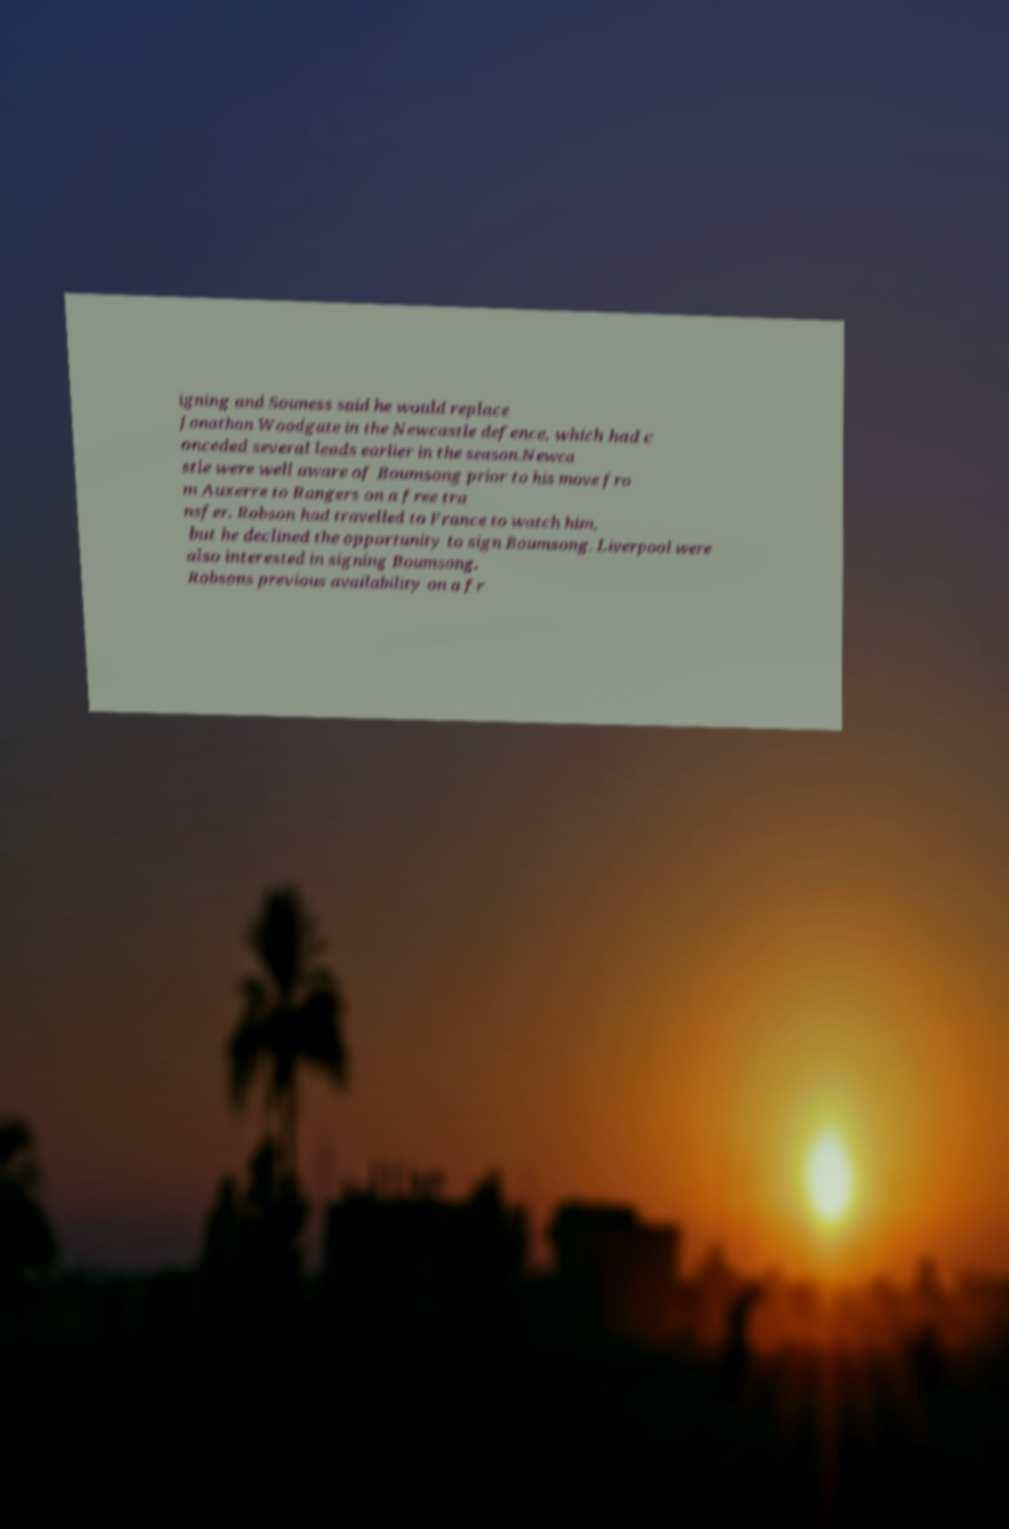There's text embedded in this image that I need extracted. Can you transcribe it verbatim? igning and Souness said he would replace Jonathan Woodgate in the Newcastle defence, which had c onceded several leads earlier in the season.Newca stle were well aware of Boumsong prior to his move fro m Auxerre to Rangers on a free tra nsfer. Robson had travelled to France to watch him, but he declined the opportunity to sign Boumsong. Liverpool were also interested in signing Boumsong. Robsons previous availability on a fr 